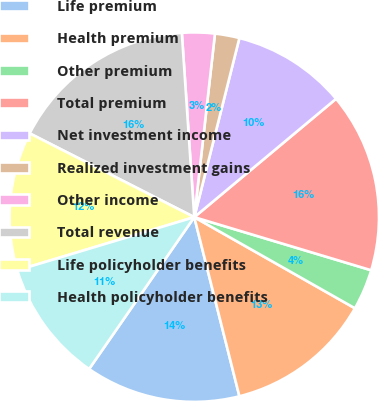<chart> <loc_0><loc_0><loc_500><loc_500><pie_chart><fcel>Life premium<fcel>Health premium<fcel>Other premium<fcel>Total premium<fcel>Net investment income<fcel>Realized investment gains<fcel>Other income<fcel>Total revenue<fcel>Life policyholder benefits<fcel>Health policyholder benefits<nl><fcel>13.57%<fcel>12.86%<fcel>3.57%<fcel>15.71%<fcel>10.0%<fcel>2.14%<fcel>2.86%<fcel>16.43%<fcel>12.14%<fcel>10.71%<nl></chart> 